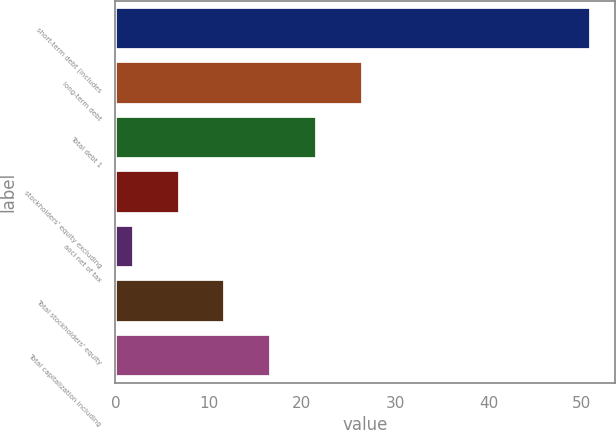<chart> <loc_0><loc_0><loc_500><loc_500><bar_chart><fcel>short-term debt (includes<fcel>long-term debt<fcel>Total debt 1<fcel>stockholders' equity excluding<fcel>aoci net of tax<fcel>Total stockholders' equity<fcel>Total capitalization including<nl><fcel>51<fcel>26.5<fcel>21.6<fcel>6.9<fcel>2<fcel>11.8<fcel>16.7<nl></chart> 